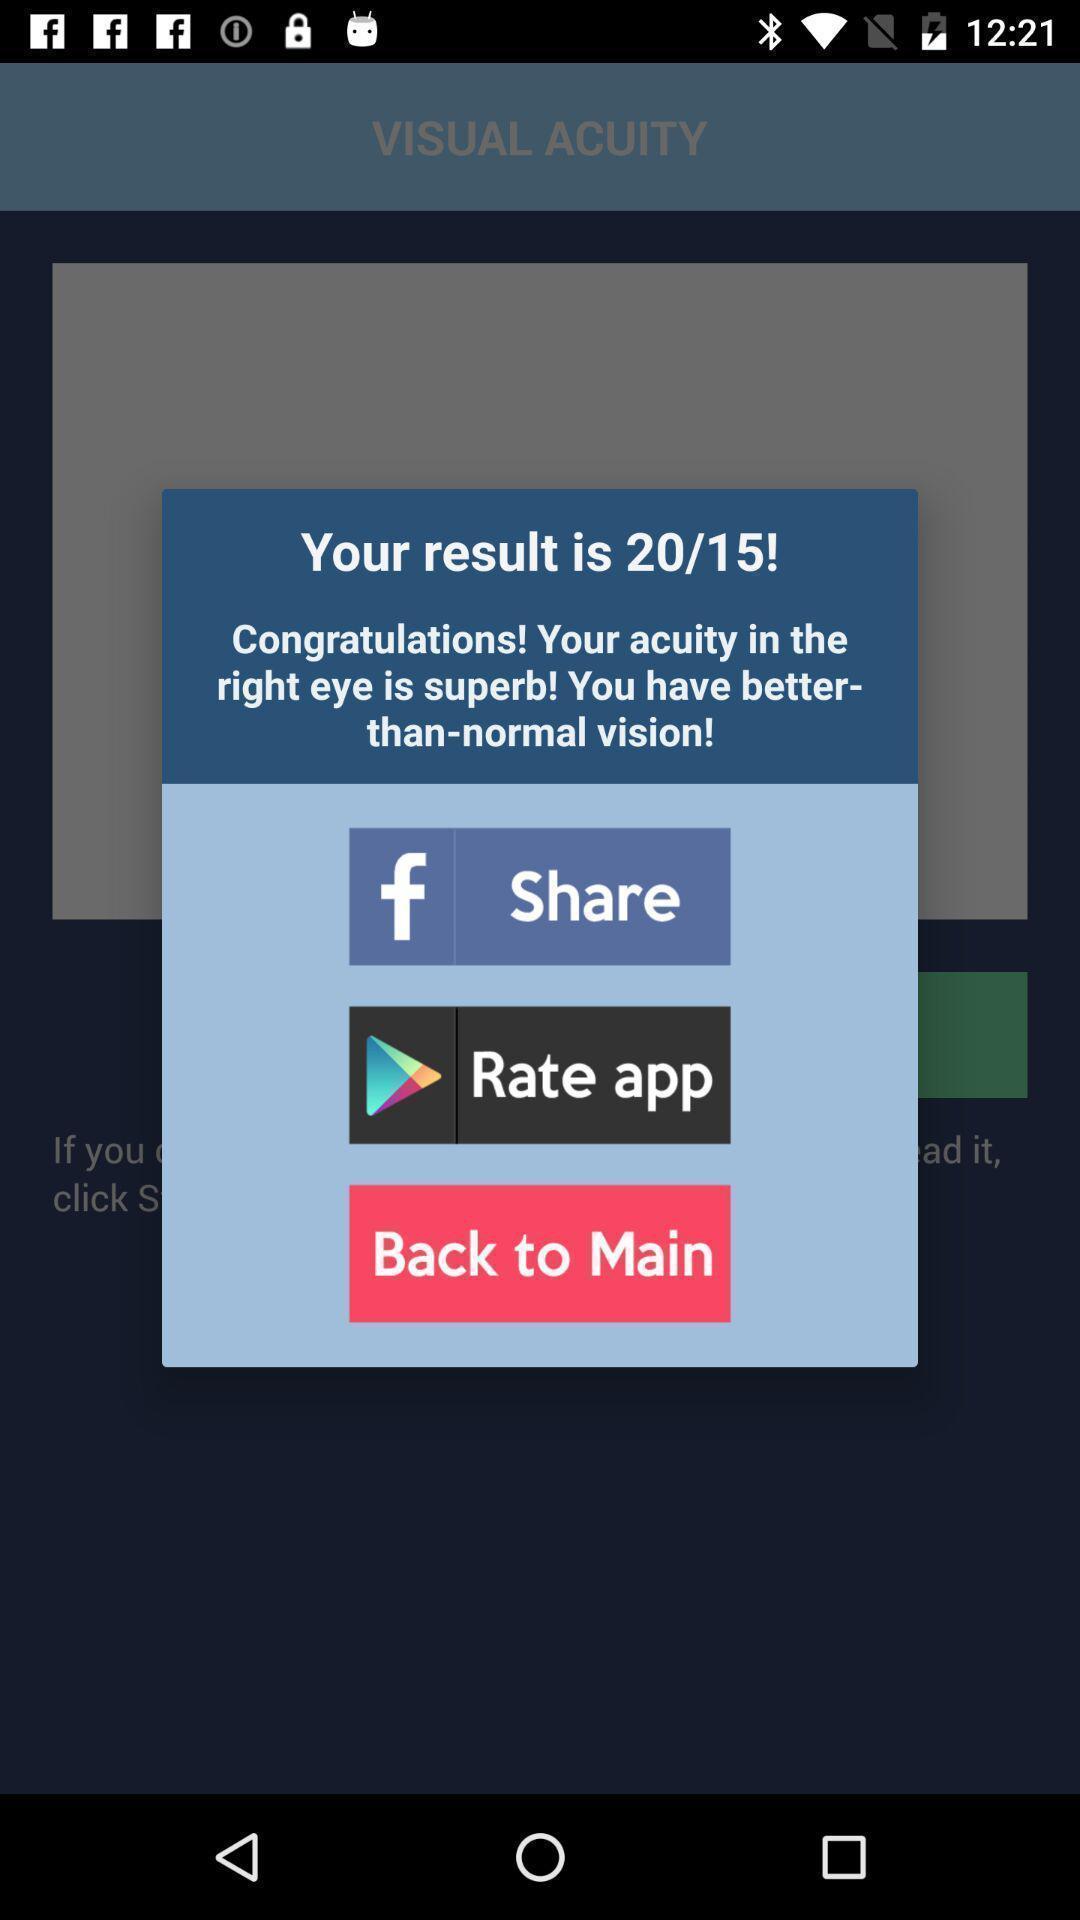What is the overall content of this screenshot? Pop-up about the result on eye testing app. 